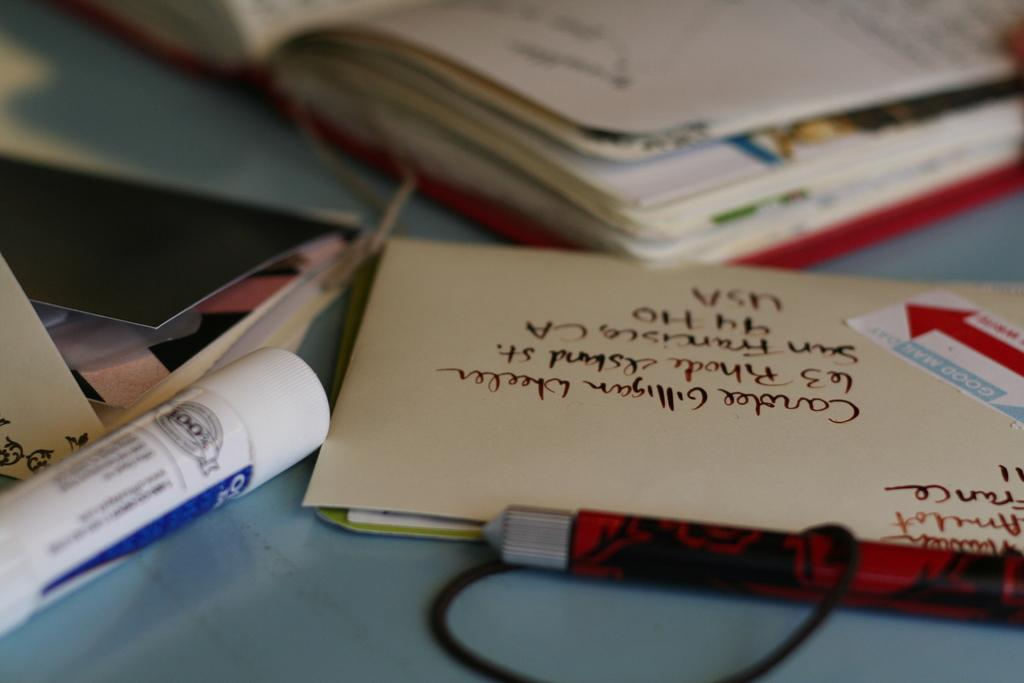<image>
Give a short and clear explanation of the subsequent image. A letter on a desk has been addressed to a Carlee Wheeler in the USA 